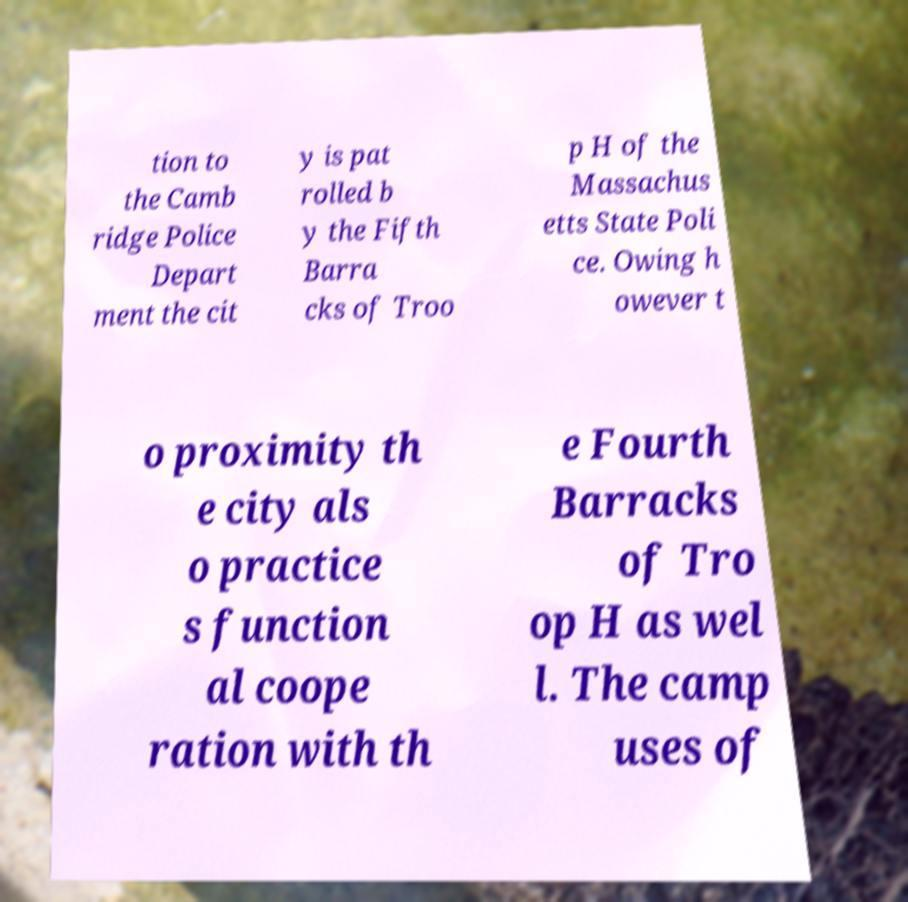Can you accurately transcribe the text from the provided image for me? tion to the Camb ridge Police Depart ment the cit y is pat rolled b y the Fifth Barra cks of Troo p H of the Massachus etts State Poli ce. Owing h owever t o proximity th e city als o practice s function al coope ration with th e Fourth Barracks of Tro op H as wel l. The camp uses of 